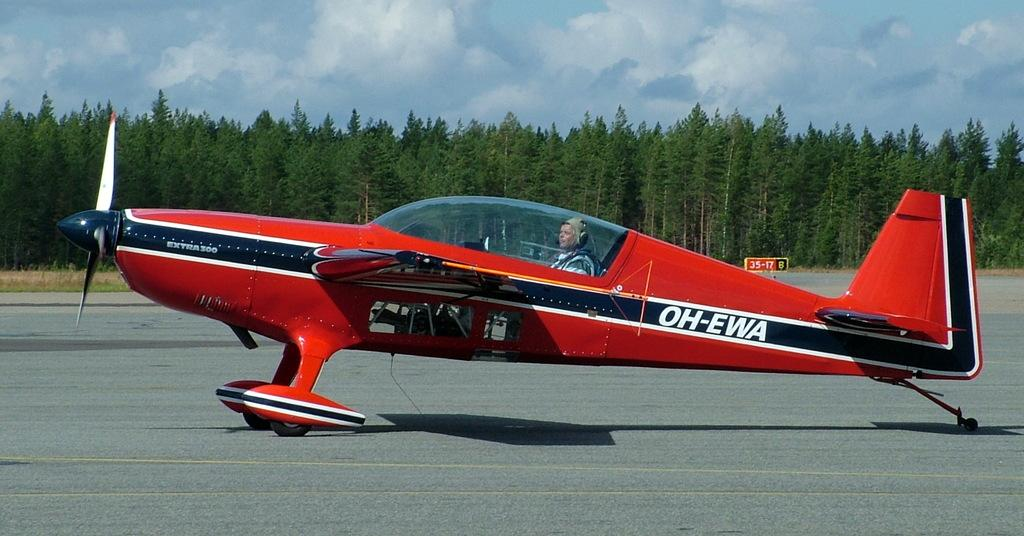Provide a one-sentence caption for the provided image. A red airplane with the letters OH-EWA on the side. 